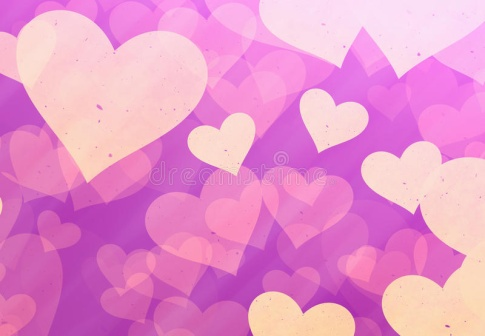Can you describe the atmosphere this image conveys? This image conveys a dreamy and romantic atmosphere. The soothing shades of purple combined with the soft pink and yellow hearts create an ambiance of warmth and affection. The gradient in the background adds depth and a touch of sophistication, while the random scattering of hearts gives the illustration a whimsical and playful feel. It's akin to a dreamy, affectionate visualization one might associate with feelings of love and joy. What emotions do you think the artist tried to evoke with this image? The artist likely aimed to evoke emotions of love, warmth, and joy with this image. The gentle colors and soft shapes of the hearts convey a sense of tenderness and affection, while the playful arrangement suggests spontaneity and happiness. The overall effect is comforting and uplifting, designed to make the viewer feel cherished and delighted. 